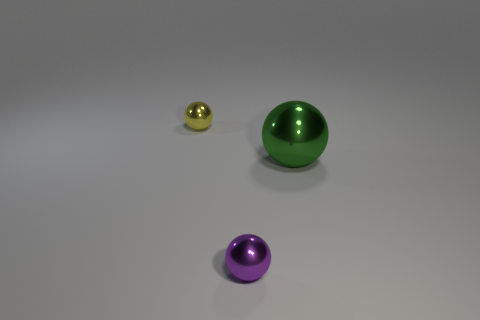Add 3 yellow shiny balls. How many objects exist? 6 Subtract all purple metallic balls. How many balls are left? 2 Subtract all green spheres. How many spheres are left? 2 Subtract all brown spheres. Subtract all purple blocks. How many spheres are left? 3 Subtract all gray cylinders. How many yellow balls are left? 1 Subtract all small metallic balls. Subtract all purple metallic things. How many objects are left? 0 Add 3 tiny spheres. How many tiny spheres are left? 5 Add 1 big blue cylinders. How many big blue cylinders exist? 1 Subtract 0 green cylinders. How many objects are left? 3 